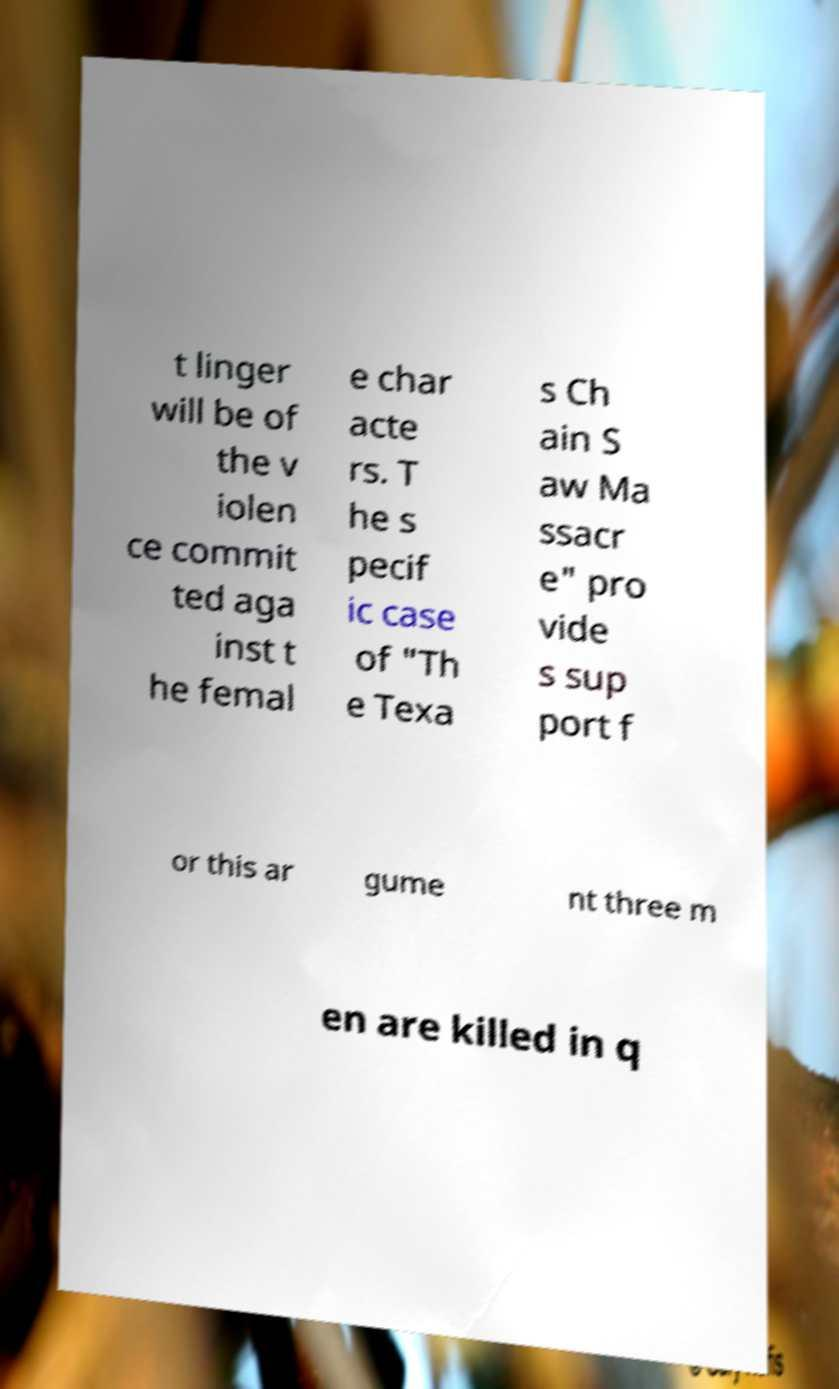There's text embedded in this image that I need extracted. Can you transcribe it verbatim? t linger will be of the v iolen ce commit ted aga inst t he femal e char acte rs. T he s pecif ic case of "Th e Texa s Ch ain S aw Ma ssacr e" pro vide s sup port f or this ar gume nt three m en are killed in q 